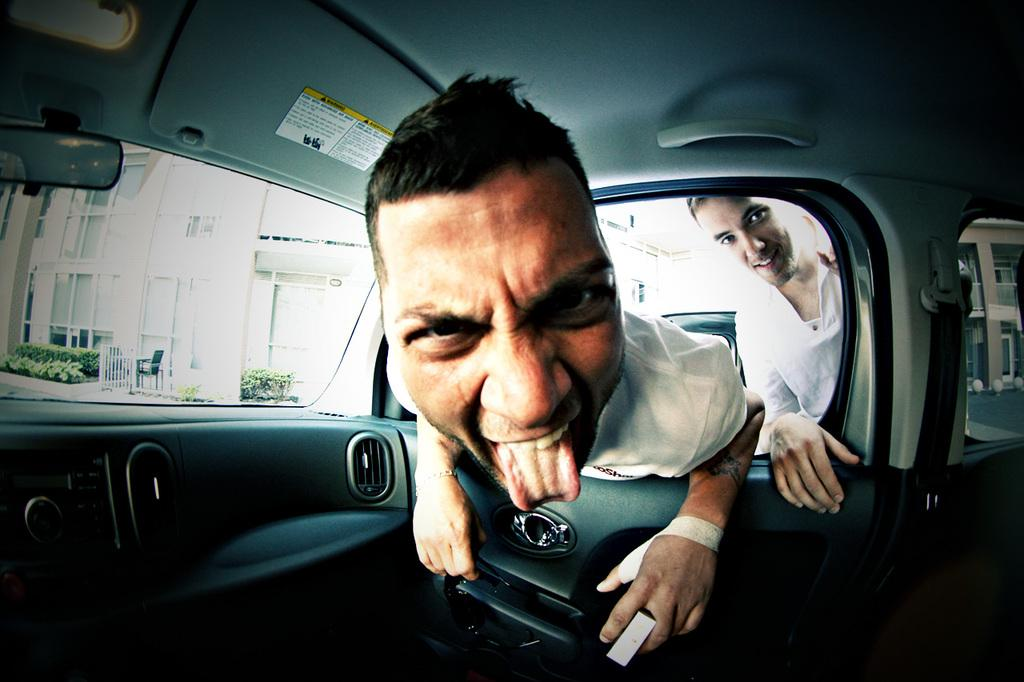What is the setting of the image? The image shows the inside view of a vehicle. How many people are in the vehicle? There are two men in the vehicle. Can you describe the facial expression of one of the men? One of the men is smiling. What can be seen in the background of the image? There are buildings and plants visible in the background. How many times does the bee fly around the vehicle in the image? There is no bee present in the image, so it cannot be determined how many times it flies around the vehicle. 